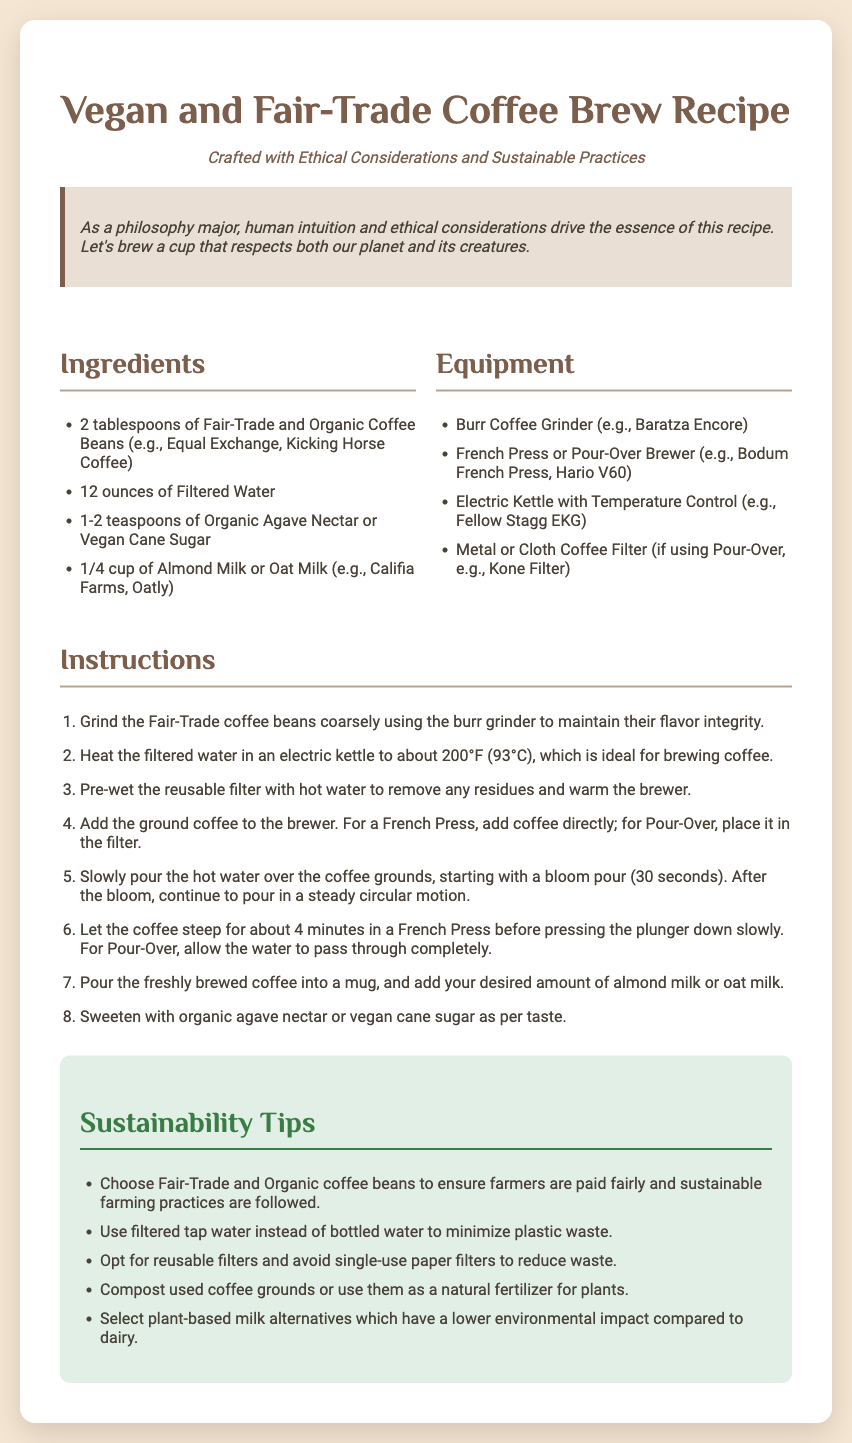What type of coffee beans should be used? The recipe specifies that Fair-Trade and Organic Coffee Beans should be used.
Answer: Fair-Trade and Organic Coffee Beans How many ounces of water are needed? The recipe states that 12 ounces of Filtered Water is required.
Answer: 12 ounces What is the recommended brewing temperature? The document indicates the ideal temperature for brewing coffee is about 200°F (93°C).
Answer: 200°F What should be added to sweeten the coffee? The recipe mentions adding Organic Agave Nectar or Vegan Cane Sugar to sweeten the coffee.
Answer: Organic Agave Nectar or Vegan Cane Sugar What is one sustainability tip provided? The document lists several sustainability tips, one example being to use filtered tap water instead of bottled water.
Answer: Use filtered tap water How long should coffee steep in a French Press? According to the instructions, the coffee should steep for about 4 minutes in a French Press.
Answer: 4 minutes What type of milk alternatives are recommended? The recipe suggests using Almond Milk or Oat Milk as plant-based alternatives.
Answer: Almond Milk or Oat Milk What is the purpose of pre-wetting the reusable filter? The instructions say to pre-wet the reusable filter to remove residues and warm the brewer.
Answer: Remove residues and warm the brewer What equipment is suggested for grinding coffee? The document recommends using a Burr Coffee Grinder for grinding coffee.
Answer: Burr Coffee Grinder 